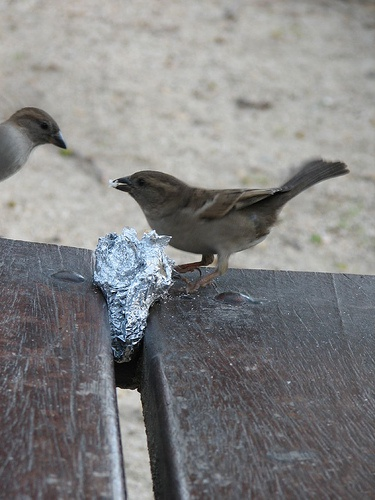Describe the objects in this image and their specific colors. I can see bench in darkgray, gray, and black tones, bird in darkgray, gray, and black tones, and bird in darkgray, gray, and black tones in this image. 